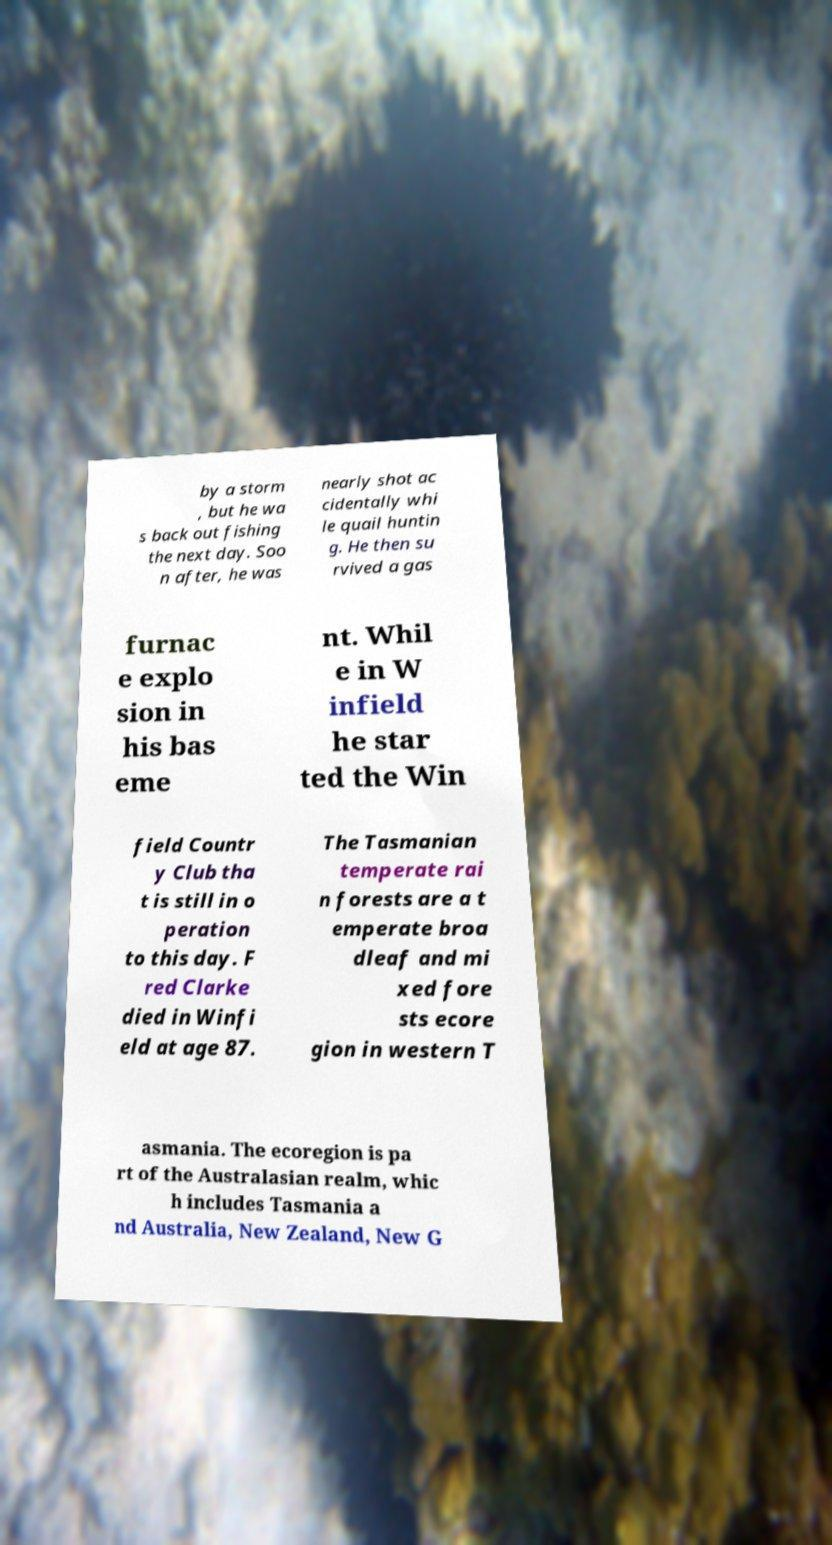What messages or text are displayed in this image? I need them in a readable, typed format. by a storm , but he wa s back out fishing the next day. Soo n after, he was nearly shot ac cidentally whi le quail huntin g. He then su rvived a gas furnac e explo sion in his bas eme nt. Whil e in W infield he star ted the Win field Countr y Club tha t is still in o peration to this day. F red Clarke died in Winfi eld at age 87. The Tasmanian temperate rai n forests are a t emperate broa dleaf and mi xed fore sts ecore gion in western T asmania. The ecoregion is pa rt of the Australasian realm, whic h includes Tasmania a nd Australia, New Zealand, New G 